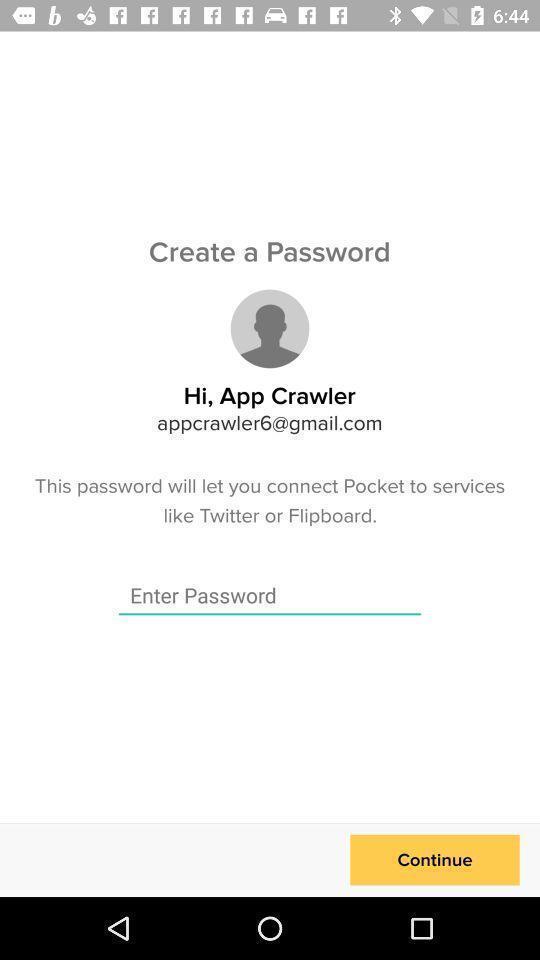Provide a textual representation of this image. Screen showing a field for creating a password. 